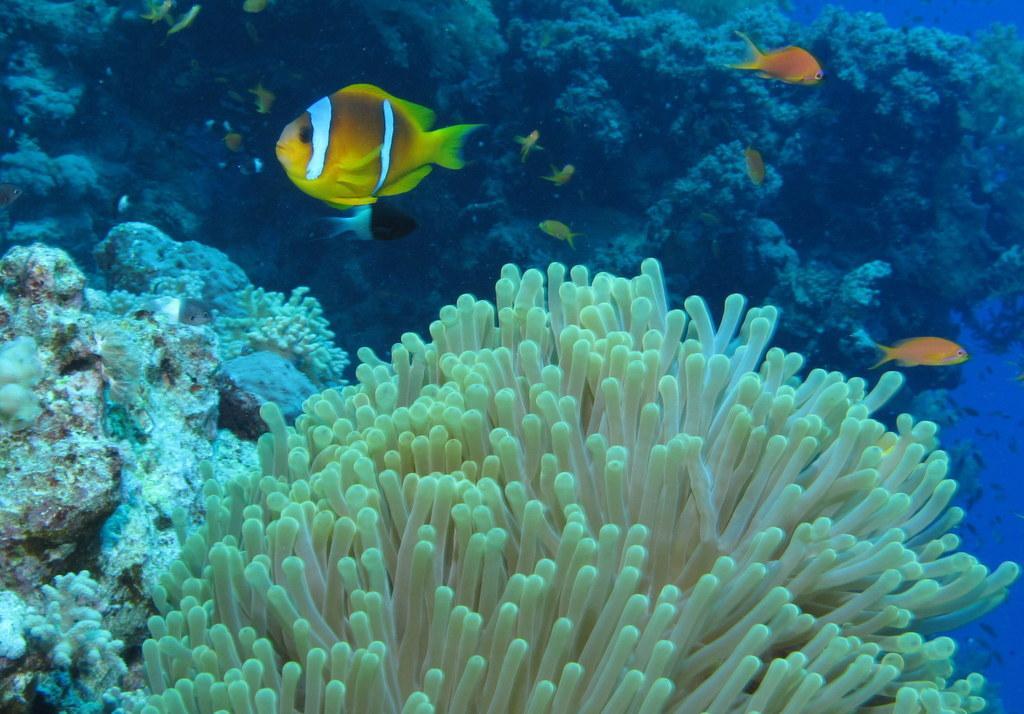In one or two sentences, can you explain what this image depicts? This image is taken underwater, which consists of a few fishes and they are surrounded by underwater plants and rocks. 